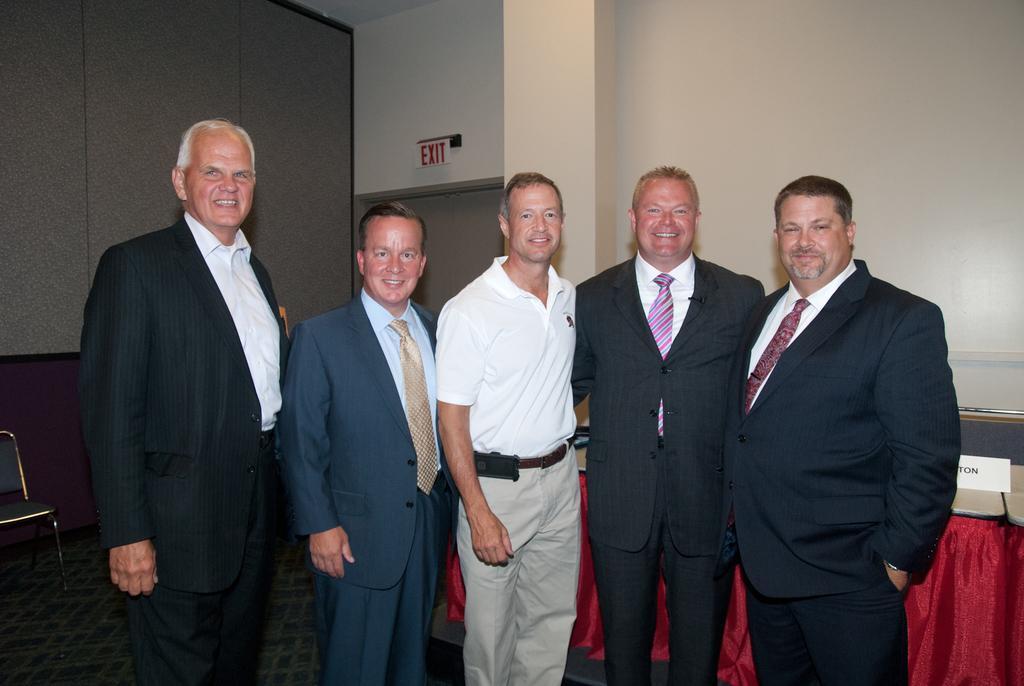How would you summarize this image in a sentence or two? In this image I can see there are few persons standing on the floor and they are smiling and in the background I can see the wall and on the left side I can see a chair kept on the floor , on the right side I can see a red color cloth. 